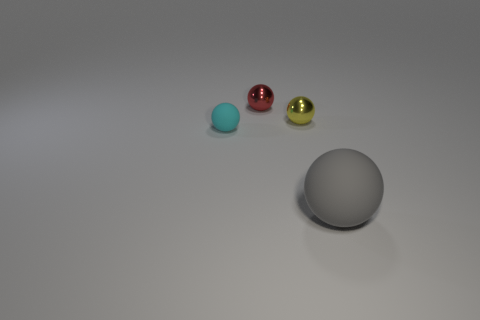Subtract all tiny spheres. How many spheres are left? 1 Subtract 2 spheres. How many spheres are left? 2 Subtract all cyan balls. How many balls are left? 3 Add 3 blue matte blocks. How many objects exist? 7 Subtract all blue balls. Subtract all brown cylinders. How many balls are left? 4 Subtract all metal things. Subtract all small red spheres. How many objects are left? 1 Add 4 red things. How many red things are left? 5 Add 2 spheres. How many spheres exist? 6 Subtract 0 green spheres. How many objects are left? 4 